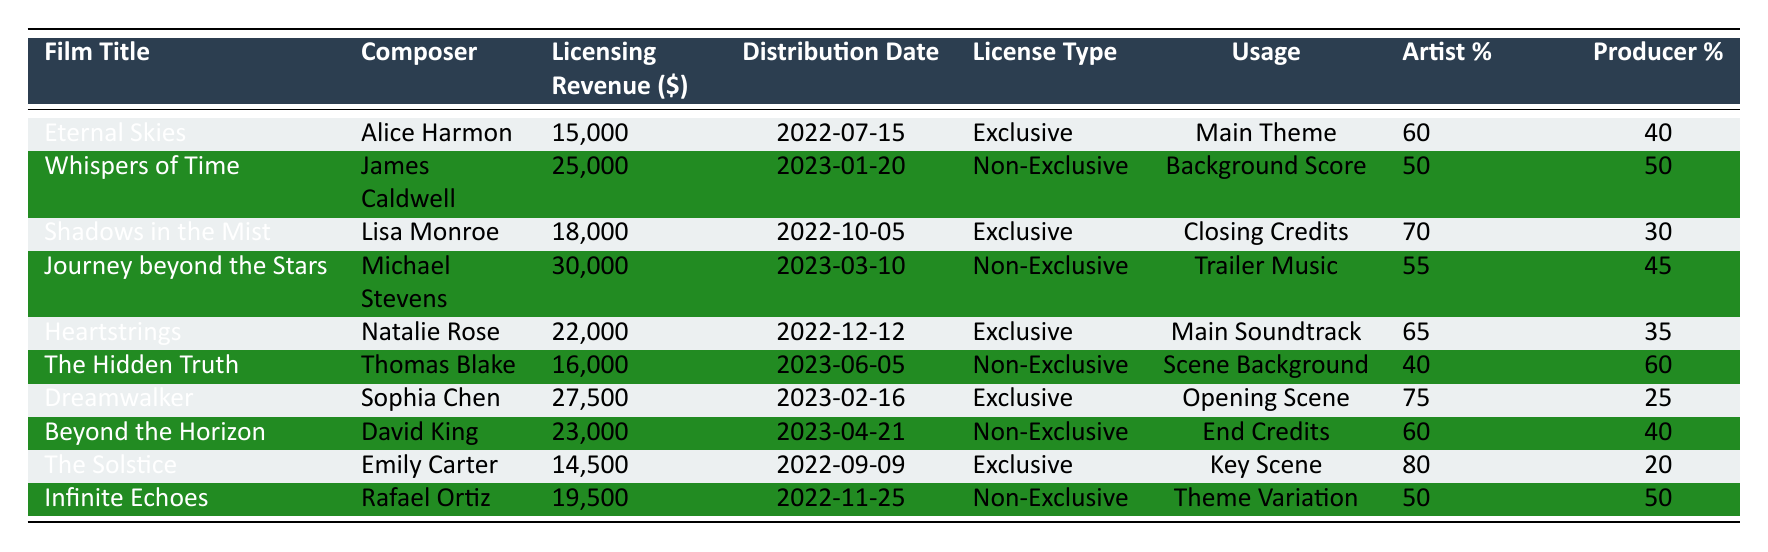What is the highest licensing revenue generated among the films listed? The highest licensing revenue can be found by comparing the values in the "Licensing Revenue" column. The maximum value is 30,000 from "Journey beyond the Stars."
Answer: 30,000 Which composer earned the highest percentage from the licensing revenue? To find the highest percentage to an artist, compare all values in the "Artist %" column. "The Solstice" has the highest percentage at 80%.
Answer: 80% What was the distribution date of the film "Heartstrings"? The distribution date for "Heartstrings" is directly listed in the table under the "Distribution Date" column. It is December 12, 2022.
Answer: 2022-12-12 How many films had exclusive licensing deals? Count the number of entries in the "License Type" column that are marked as "Exclusive." There are 5 films with exclusive licensing.
Answer: 5 What is the average artist percentage of all the composers listed? To calculate the average artist percentage, sum all the values in the "Artist %" column (60 + 50 + 70 + 55 + 65 + 40 + 75 + 60 + 80 + 50 = 715) and divide by the total number of films (10) which gives 715/10 = 71.5.
Answer: 71.5 Is "Dreamwalker" a non-exclusive licensing deal? Check the "License Type" for "Dreamwalker," which is labeled as "Exclusive," thereby confirming it is not non-exclusive.
Answer: No What percentage does the producer receive from "The Hidden Truth"? The percentage allocated to the producer for "The Hidden Truth" is directly listed in the "Producer %" column, which is 60%.
Answer: 60% How much revenue was generated from non-exclusive licenses? Sum the "Licensing Revenue" for all films marked as "Non-Exclusive." The total is (25,000 + 30,000 + 16,000 + 19,500) = 90,500.
Answer: 90,500 Which film had the lowest licensing revenue, and what was that amount? Look through the "Licensing Revenue" column to find the minimum value, which is 14,500 from "The Solstice."
Answer: 14,500 What is the difference between the highest and lowest artist percentage? Determine the highest artist percentage (80% from "The Solstice") and the lowest (40% from "The Hidden Truth"), then subtract the two (80 - 40 = 40).
Answer: 40 